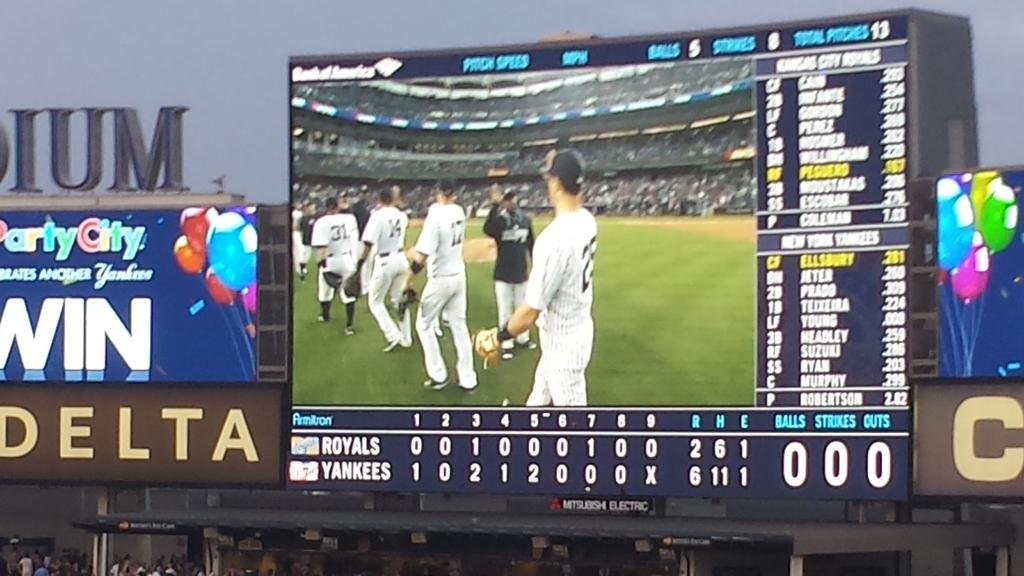<image>
Render a clear and concise summary of the photo. A large display at a sporting event is clearly sponsored by Bank of America. 